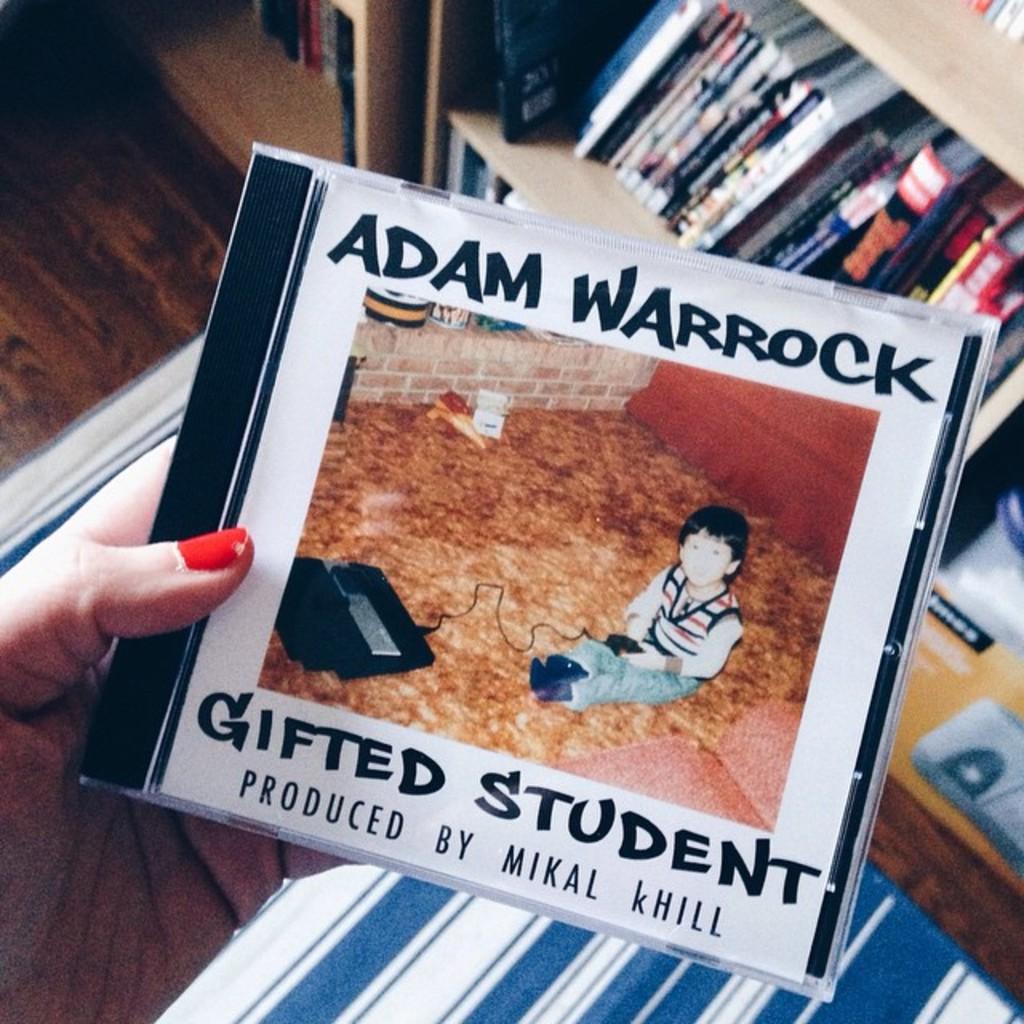Who produced the album?
Give a very brief answer. Mikal khill. 